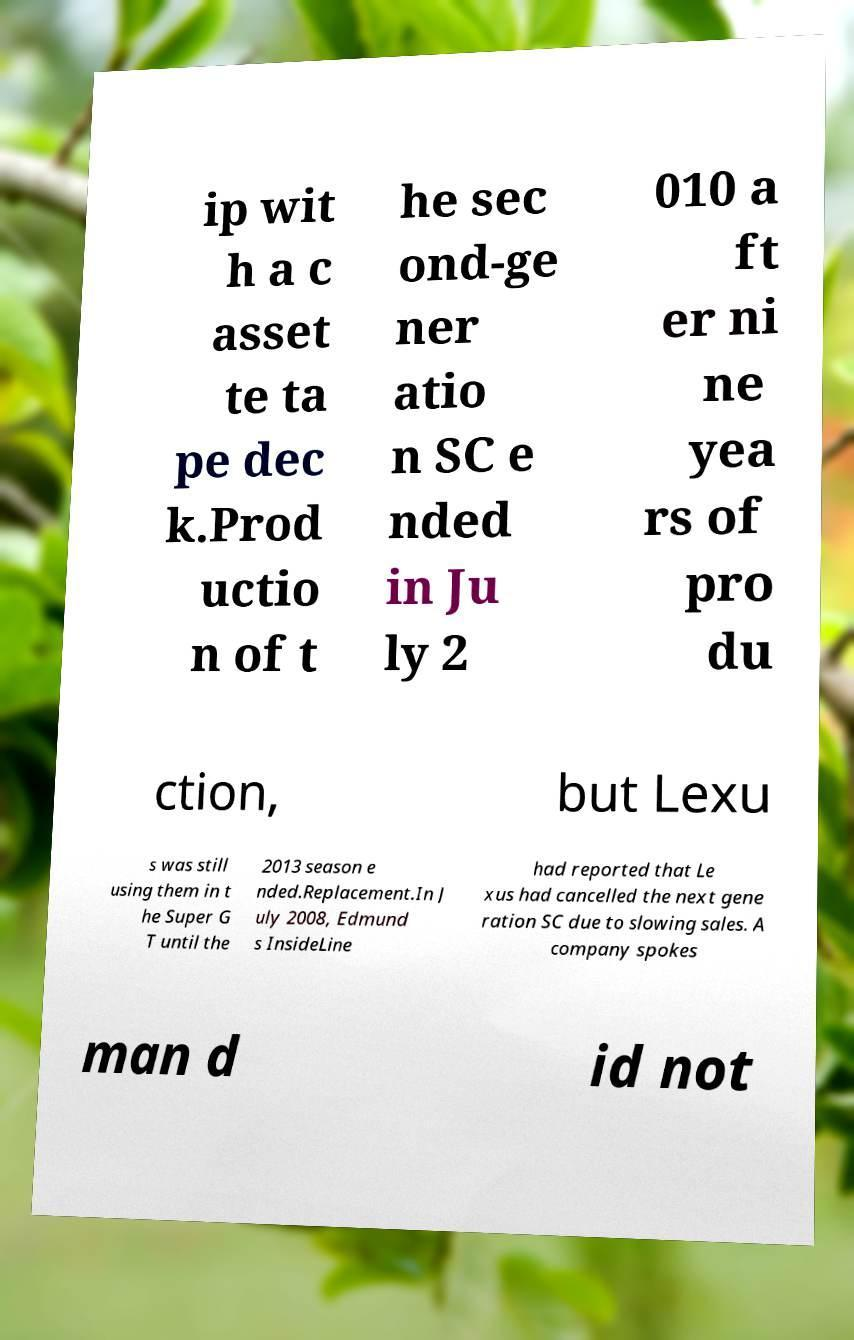What messages or text are displayed in this image? I need them in a readable, typed format. ip wit h a c asset te ta pe dec k.Prod uctio n of t he sec ond-ge ner atio n SC e nded in Ju ly 2 010 a ft er ni ne yea rs of pro du ction, but Lexu s was still using them in t he Super G T until the 2013 season e nded.Replacement.In J uly 2008, Edmund s InsideLine had reported that Le xus had cancelled the next gene ration SC due to slowing sales. A company spokes man d id not 